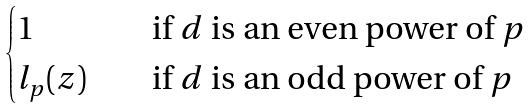Convert formula to latex. <formula><loc_0><loc_0><loc_500><loc_500>\begin{cases} 1 \quad & \text {if $d$ is an even power of $p$} \\ l _ { p } ( z ) \quad & \text {if $d$ is an odd power of $p$} \end{cases}</formula> 